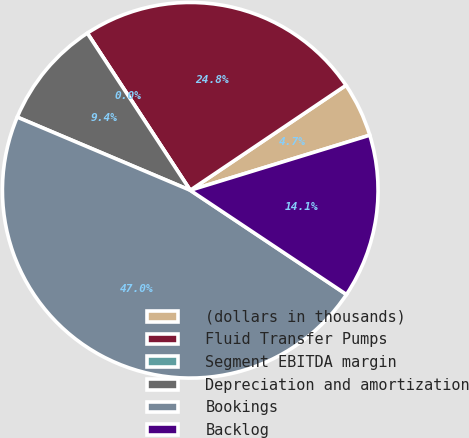Convert chart. <chart><loc_0><loc_0><loc_500><loc_500><pie_chart><fcel>(dollars in thousands)<fcel>Fluid Transfer Pumps<fcel>Segment EBITDA margin<fcel>Depreciation and amortization<fcel>Bookings<fcel>Backlog<nl><fcel>4.7%<fcel>24.79%<fcel>0.0%<fcel>9.4%<fcel>47.0%<fcel>14.1%<nl></chart> 